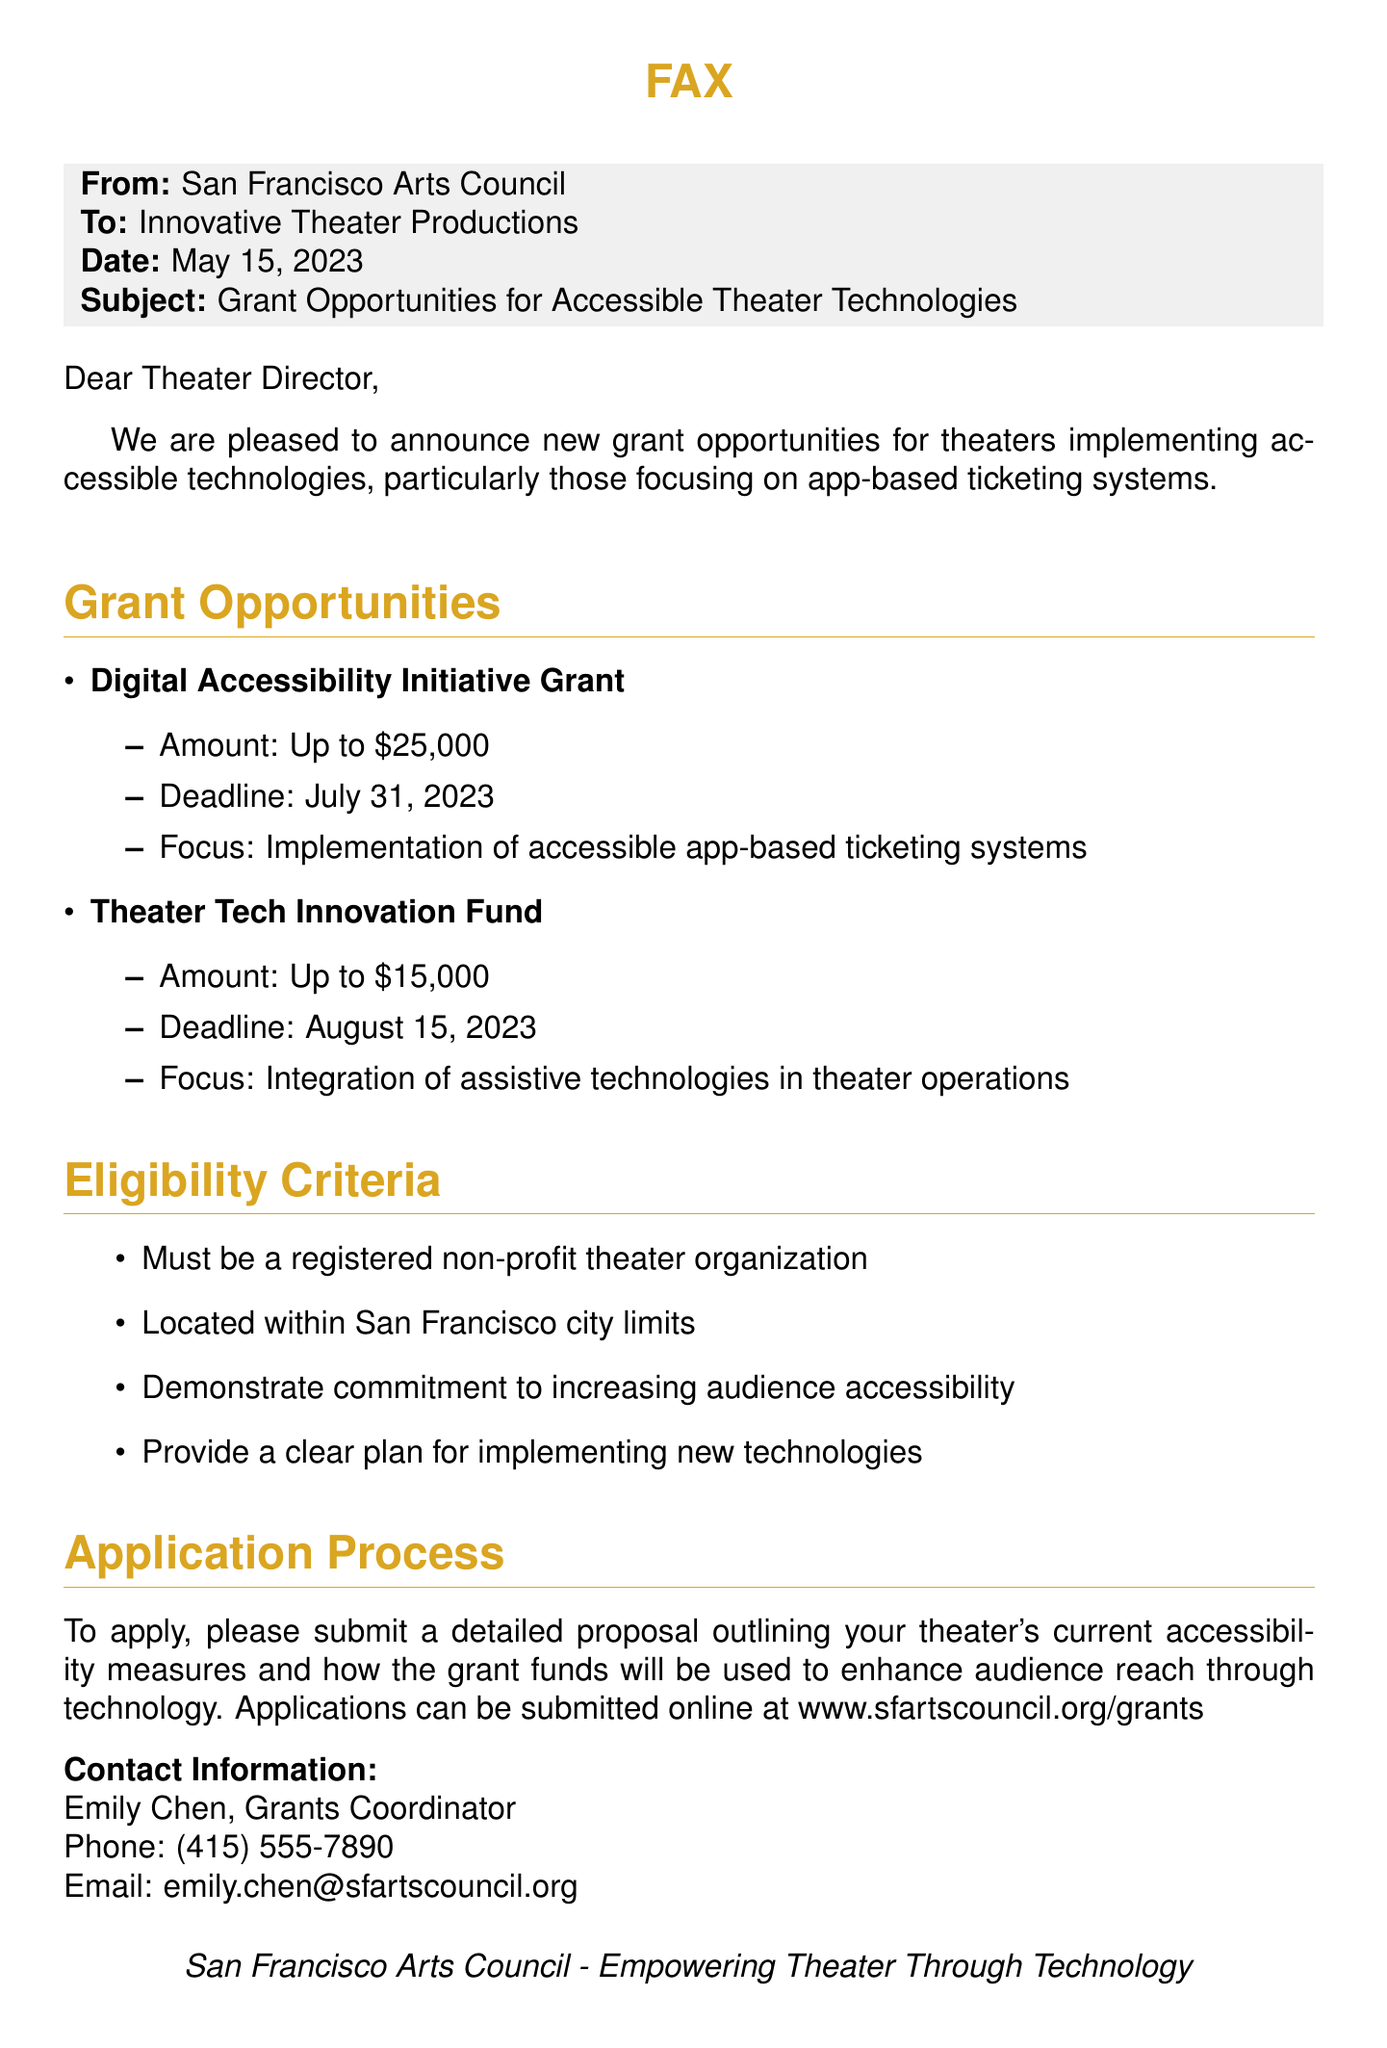What is the date of the fax? The date specified in the fax is May 15, 2023.
Answer: May 15, 2023 Who is the Grants Coordinator? The document names Emily Chen as the Grants Coordinator.
Answer: Emily Chen What is the maximum amount of the Digital Accessibility Initiative Grant? The document states that the maximum amount for this grant is up to $25,000.
Answer: Up to $25,000 What is the deadline for the Theater Tech Innovation Fund? According to the document, the deadline for this fund is August 15, 2023.
Answer: August 15, 2023 What is required to apply for the grants? Applicants must submit a detailed proposal outlining current accessibility measures.
Answer: A detailed proposal What focus does the Digital Accessibility Initiative Grant have? The focus is specifically on the implementation of accessible app-based ticketing systems.
Answer: Implementation of accessible app-based ticketing systems How much is the Theater Tech Innovation Fund worth? The fund is worth up to $15,000 as stated in the document.
Answer: Up to $15,000 Which organizations are eligible for the grants? The grants are available to registered non-profit theater organizations located within San Francisco city limits.
Answer: Registered non-profit theater organizations in San Francisco What is the main goal of the grants mentioned in the fax? The goal is to increase audience accessibility through the implementation of new technologies.
Answer: Increase audience accessibility 